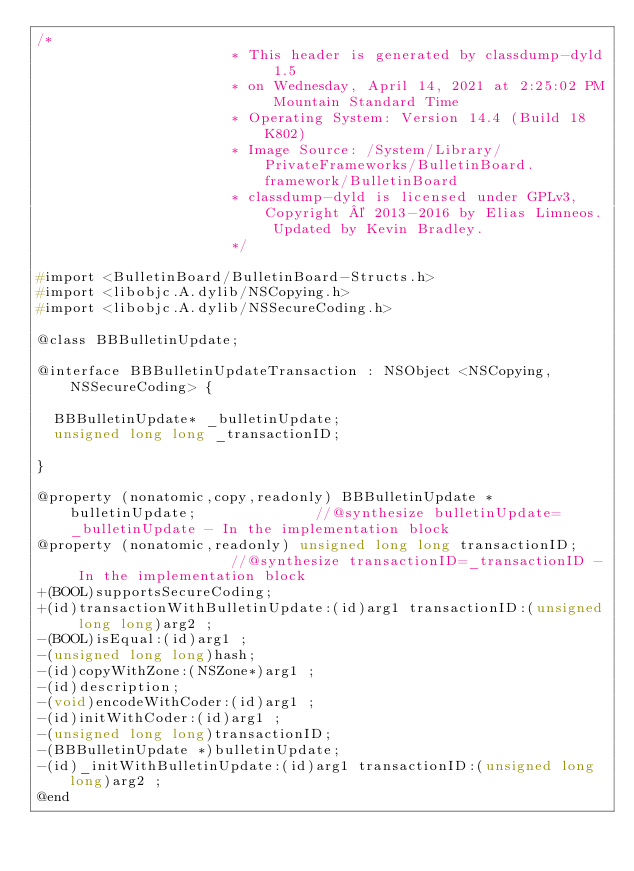<code> <loc_0><loc_0><loc_500><loc_500><_C_>/*
                       * This header is generated by classdump-dyld 1.5
                       * on Wednesday, April 14, 2021 at 2:25:02 PM Mountain Standard Time
                       * Operating System: Version 14.4 (Build 18K802)
                       * Image Source: /System/Library/PrivateFrameworks/BulletinBoard.framework/BulletinBoard
                       * classdump-dyld is licensed under GPLv3, Copyright © 2013-2016 by Elias Limneos. Updated by Kevin Bradley.
                       */

#import <BulletinBoard/BulletinBoard-Structs.h>
#import <libobjc.A.dylib/NSCopying.h>
#import <libobjc.A.dylib/NSSecureCoding.h>

@class BBBulletinUpdate;

@interface BBBulletinUpdateTransaction : NSObject <NSCopying, NSSecureCoding> {

	BBBulletinUpdate* _bulletinUpdate;
	unsigned long long _transactionID;

}

@property (nonatomic,copy,readonly) BBBulletinUpdate * bulletinUpdate;              //@synthesize bulletinUpdate=_bulletinUpdate - In the implementation block
@property (nonatomic,readonly) unsigned long long transactionID;                    //@synthesize transactionID=_transactionID - In the implementation block
+(BOOL)supportsSecureCoding;
+(id)transactionWithBulletinUpdate:(id)arg1 transactionID:(unsigned long long)arg2 ;
-(BOOL)isEqual:(id)arg1 ;
-(unsigned long long)hash;
-(id)copyWithZone:(NSZone*)arg1 ;
-(id)description;
-(void)encodeWithCoder:(id)arg1 ;
-(id)initWithCoder:(id)arg1 ;
-(unsigned long long)transactionID;
-(BBBulletinUpdate *)bulletinUpdate;
-(id)_initWithBulletinUpdate:(id)arg1 transactionID:(unsigned long long)arg2 ;
@end

</code> 